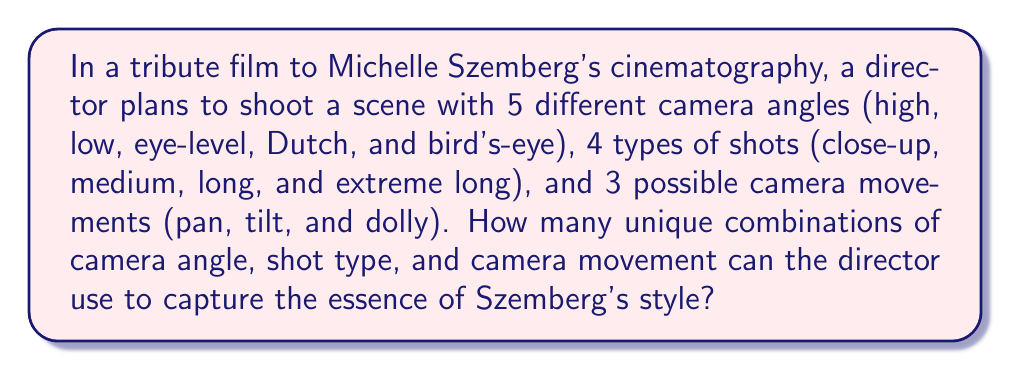Can you answer this question? To solve this problem, we'll use the multiplication principle of counting. This principle states that if we have $m$ ways of doing something and $n$ ways of doing another thing, then there are $m \times n$ ways of doing both things.

Let's break down the given information:
1. Number of camera angles: 5
2. Number of shot types: 4
3. Number of camera movements: 3

For each camera angle, we can choose any of the shot types, and for each of these combinations, we can choose any of the camera movements. Therefore:

$$ \text{Total combinations} = \text{Camera angles} \times \text{Shot types} \times \text{Camera movements} $$

$$ \text{Total combinations} = 5 \times 4 \times 3 $$

$$ \text{Total combinations} = 60 $$

Thus, the director has 60 unique combinations to choose from when capturing the scene in Szemberg's style.
Answer: 60 